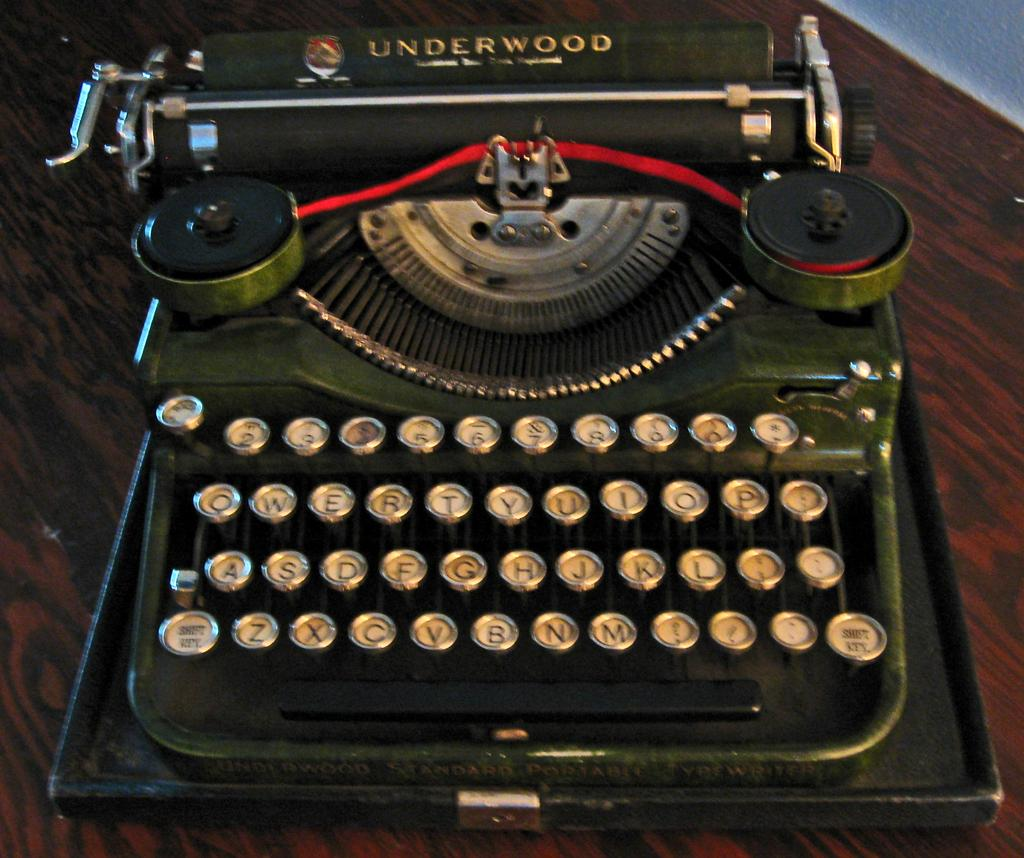<image>
Give a short and clear explanation of the subsequent image. A old Underwood type writer, the keys look in good condition. 